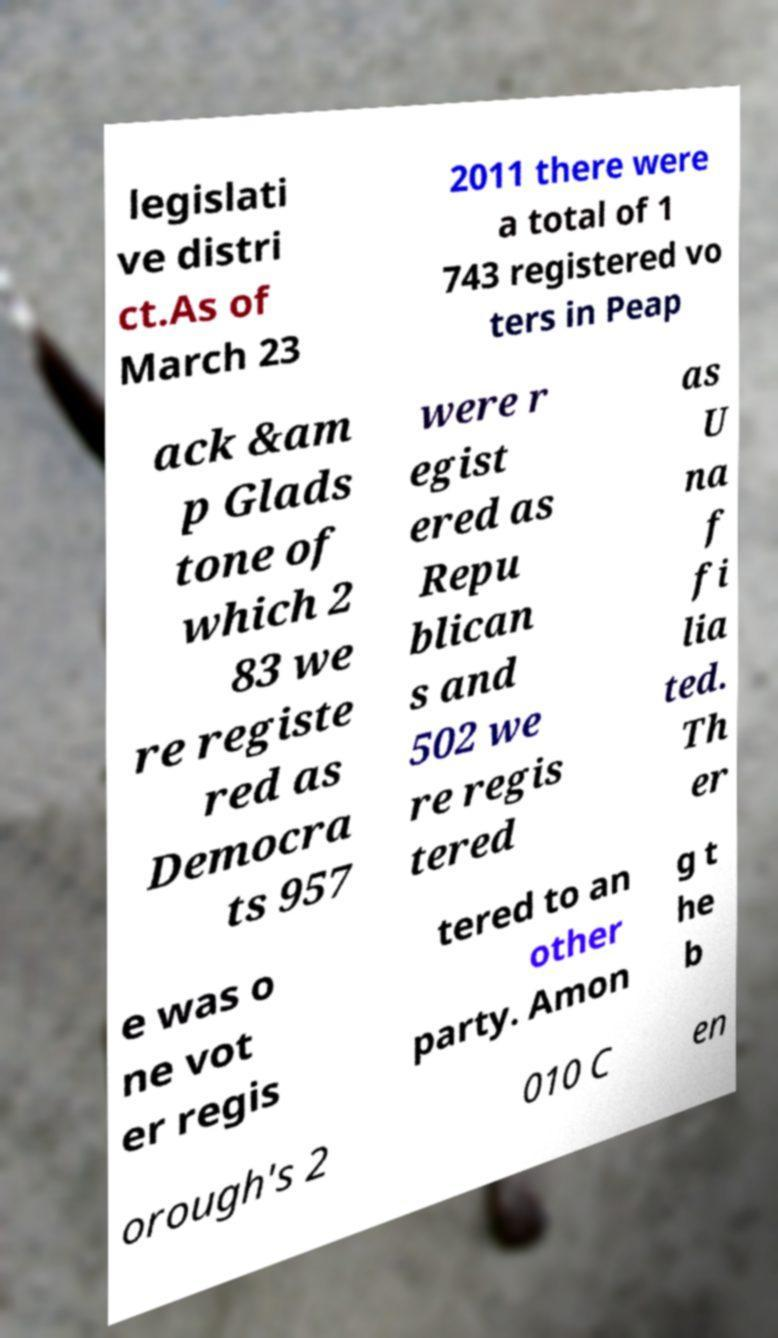Could you assist in decoding the text presented in this image and type it out clearly? legislati ve distri ct.As of March 23 2011 there were a total of 1 743 registered vo ters in Peap ack &am p Glads tone of which 2 83 we re registe red as Democra ts 957 were r egist ered as Repu blican s and 502 we re regis tered as U na f fi lia ted. Th er e was o ne vot er regis tered to an other party. Amon g t he b orough's 2 010 C en 